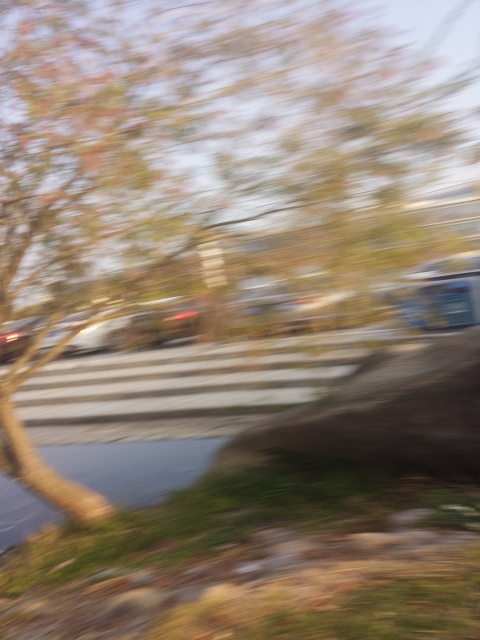What effect does the motion blur have on the image? The motion blur in this image gives rise to D. Trailing effects, where stationary objects appear to be followed by a tail or streak of blurred colors and shapes. This phenomenon creates a dynamic sense of movement and speed, albeit at the expense of clarity and sharpness in the captured scene. 